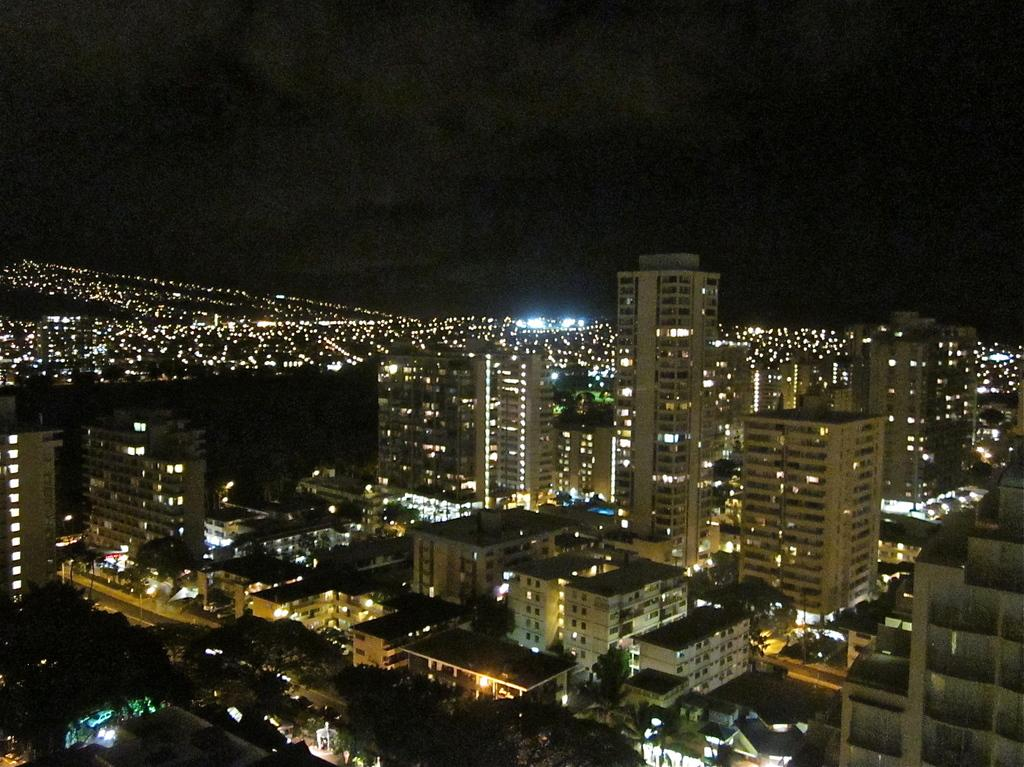What time of day is depicted in the image? The image depicts a night view. What structures can be seen in the image? There are buildings in the image. What type of vegetation is present? There are trees in the image. What is visible at the top of the image? The sky is visible at the top of the image. Can you see your friend in the image? There is no person, including a friend, present in the image. Are there any fairies visible in the image? There are no fairies present in the image. 